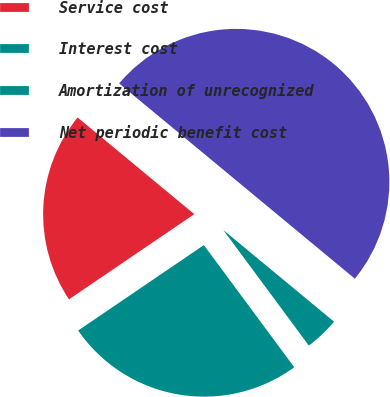<chart> <loc_0><loc_0><loc_500><loc_500><pie_chart><fcel>Service cost<fcel>Interest cost<fcel>Amortization of unrecognized<fcel>Net periodic benefit cost<nl><fcel>20.51%<fcel>25.64%<fcel>3.85%<fcel>50.0%<nl></chart> 